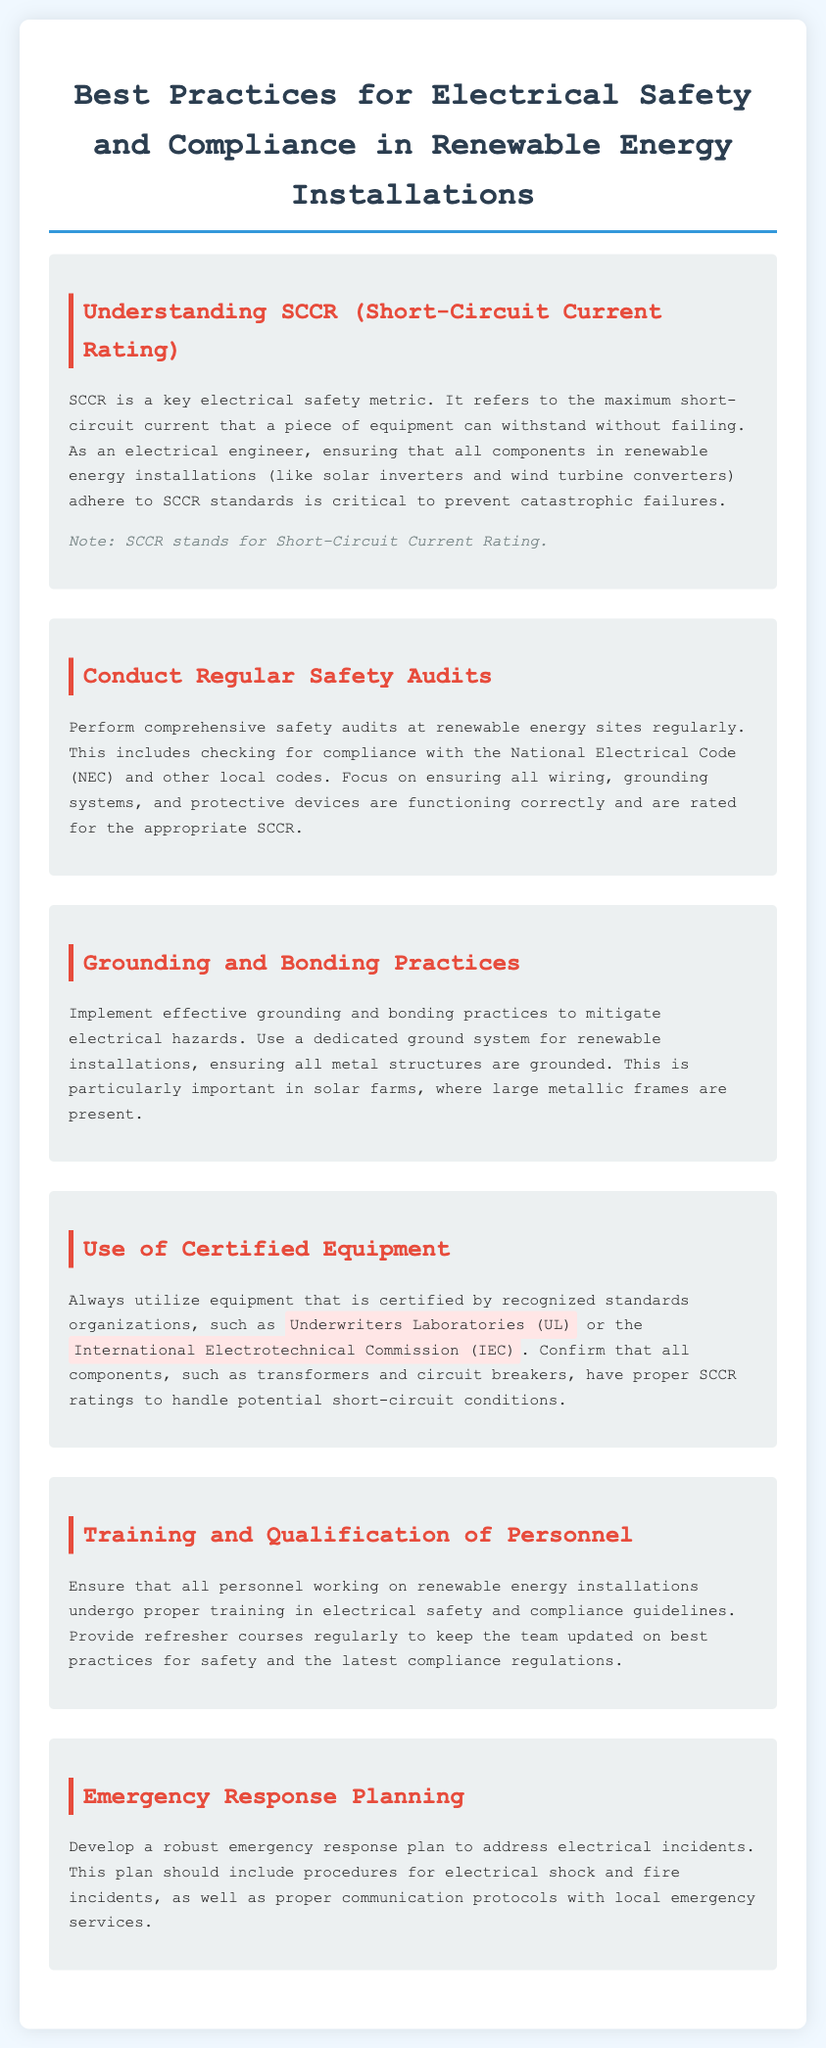What does SCCR stand for? SCCR stands for Short-Circuit Current Rating, as defined in the document.
Answer: Short-Circuit Current Rating What is the purpose of SCCR in renewable energy installations? SCCR refers to the maximum short-circuit current that equipment can withstand without failing, which is critical for safety.
Answer: Maximum short-circuit current Which organization certifies equipment mentioned in the document? The document mentions Underwriters Laboratories (UL) and the International Electrotechnical Commission (IEC) as certifying organizations.
Answer: Underwriters Laboratories (UL), International Electrotechnical Commission (IEC) What should regular safety audits check for? Safety audits should check for compliance with the National Electrical Code (NEC) and local codes, focusing on wiring, grounding, and protection.
Answer: Compliance with NEC and local codes How often should personnel undergo training? The document implies that there should be proper training and regular refresher courses for personnel working on installations.
Answer: Regularly What is emphasized as important in solar farms? The document emphasizes the importance of effective grounding and bonding practices in solar farms.
Answer: Grounding and bonding practices What type of plan should be developed for electrical incidents? The document states a robust emergency response plan should be developed for addressing electrical incidents.
Answer: Emergency response plan 